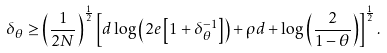<formula> <loc_0><loc_0><loc_500><loc_500>\delta _ { \theta } \geq \left ( \frac { 1 } { 2 N } \right ) ^ { \frac { 1 } { 2 } } \left [ d \log \left ( 2 e \left [ 1 + \delta _ { \theta } ^ { - 1 } \right ] \right ) + \rho d + \log \left ( \frac { 2 } { 1 - \theta } \right ) \right ] ^ { \frac { 1 } { 2 } } .</formula> 